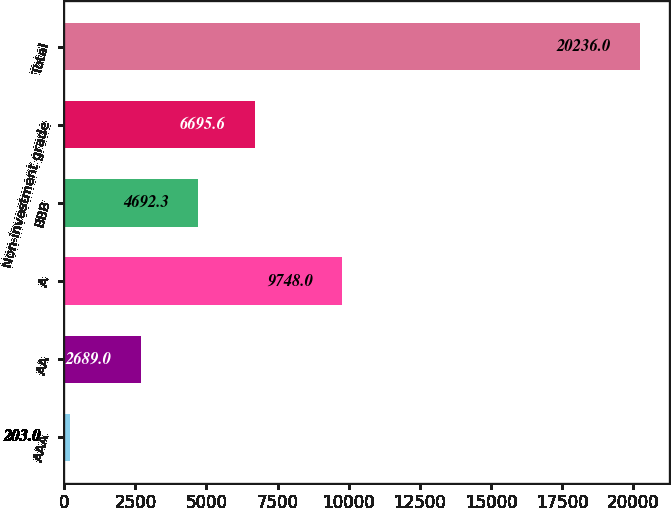<chart> <loc_0><loc_0><loc_500><loc_500><bar_chart><fcel>AAA<fcel>AA<fcel>A<fcel>BBB<fcel>Non-investment grade<fcel>Total<nl><fcel>203<fcel>2689<fcel>9748<fcel>4692.3<fcel>6695.6<fcel>20236<nl></chart> 